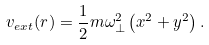<formula> <loc_0><loc_0><loc_500><loc_500>v _ { e x t } ( { r } ) = \frac { 1 } { 2 } m \omega _ { \bot } ^ { 2 } \left ( x ^ { 2 } + y ^ { 2 } \right ) .</formula> 